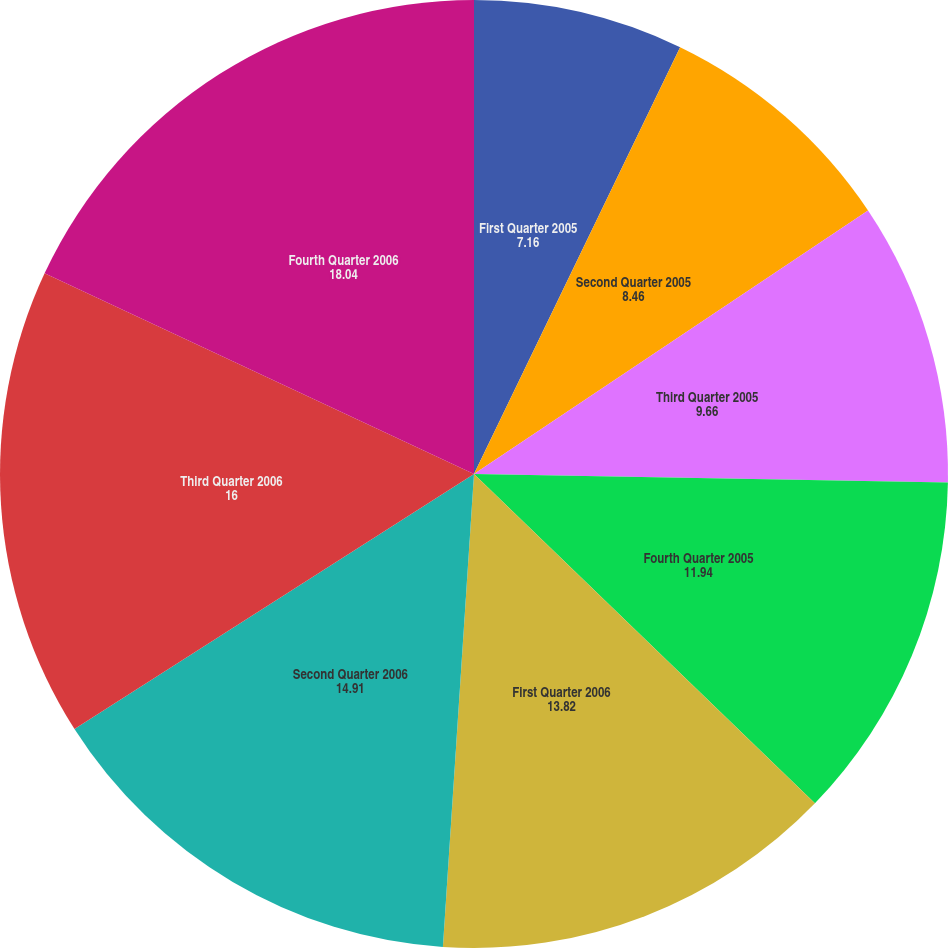Convert chart. <chart><loc_0><loc_0><loc_500><loc_500><pie_chart><fcel>First Quarter 2005<fcel>Second Quarter 2005<fcel>Third Quarter 2005<fcel>Fourth Quarter 2005<fcel>First Quarter 2006<fcel>Second Quarter 2006<fcel>Third Quarter 2006<fcel>Fourth Quarter 2006<nl><fcel>7.16%<fcel>8.46%<fcel>9.66%<fcel>11.94%<fcel>13.82%<fcel>14.91%<fcel>16.0%<fcel>18.04%<nl></chart> 